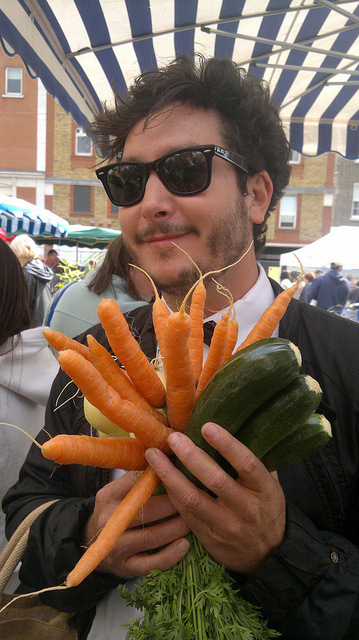<image>What kind of air conditioning do the people have living in the building? I don't know what kind of air conditioning the people have living in the building, it could be window mounted, centralized or none at all. What kind of air conditioning do the people have living in the building? It is ambiguous what kind of air conditioning the people have living in the building. It can be seen both window mounted and central air conditioning. 